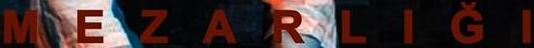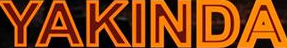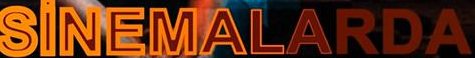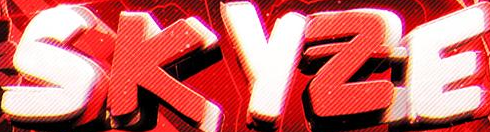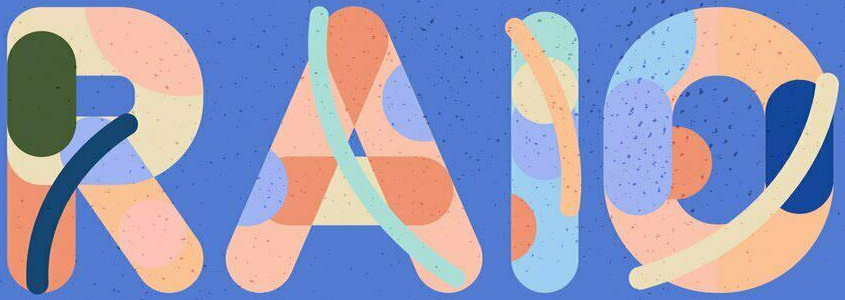What text appears in these images from left to right, separated by a semicolon? MEZARLIĞI; YAKINDA; SiNEMALARDA; SKYZE; RAIO 